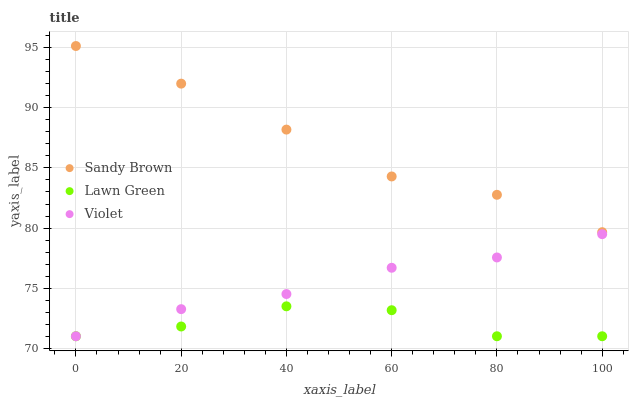Does Lawn Green have the minimum area under the curve?
Answer yes or no. Yes. Does Sandy Brown have the maximum area under the curve?
Answer yes or no. Yes. Does Violet have the minimum area under the curve?
Answer yes or no. No. Does Violet have the maximum area under the curve?
Answer yes or no. No. Is Violet the smoothest?
Answer yes or no. Yes. Is Lawn Green the roughest?
Answer yes or no. Yes. Is Sandy Brown the smoothest?
Answer yes or no. No. Is Sandy Brown the roughest?
Answer yes or no. No. Does Lawn Green have the lowest value?
Answer yes or no. Yes. Does Sandy Brown have the lowest value?
Answer yes or no. No. Does Sandy Brown have the highest value?
Answer yes or no. Yes. Does Violet have the highest value?
Answer yes or no. No. Is Lawn Green less than Sandy Brown?
Answer yes or no. Yes. Is Sandy Brown greater than Lawn Green?
Answer yes or no. Yes. Does Violet intersect Lawn Green?
Answer yes or no. Yes. Is Violet less than Lawn Green?
Answer yes or no. No. Is Violet greater than Lawn Green?
Answer yes or no. No. Does Lawn Green intersect Sandy Brown?
Answer yes or no. No. 